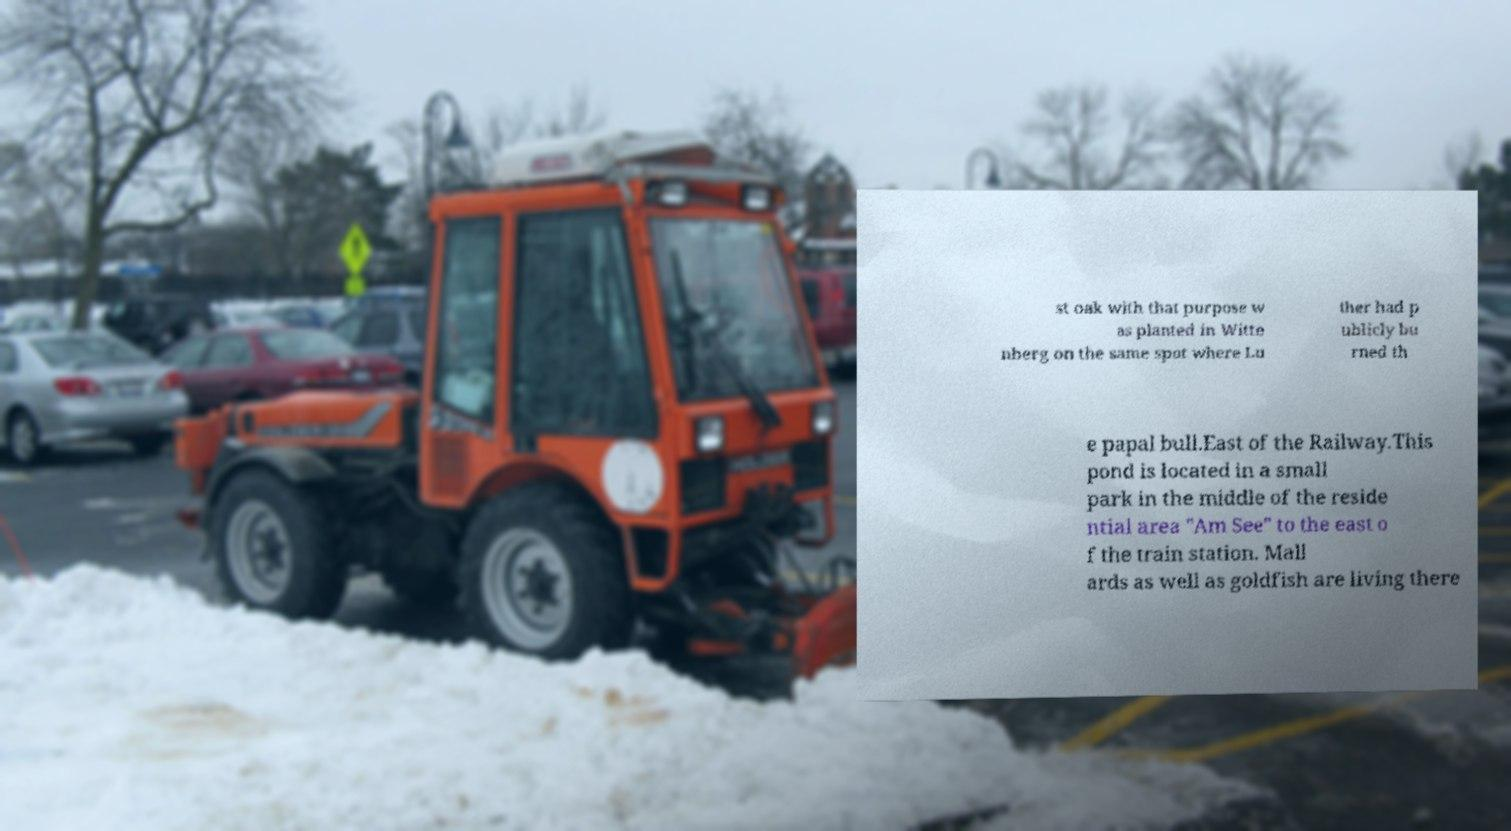Could you assist in decoding the text presented in this image and type it out clearly? st oak with that purpose w as planted in Witte nberg on the same spot where Lu ther had p ublicly bu rned th e papal bull.East of the Railway.This pond is located in a small park in the middle of the reside ntial area "Am See" to the east o f the train station. Mall ards as well as goldfish are living there 